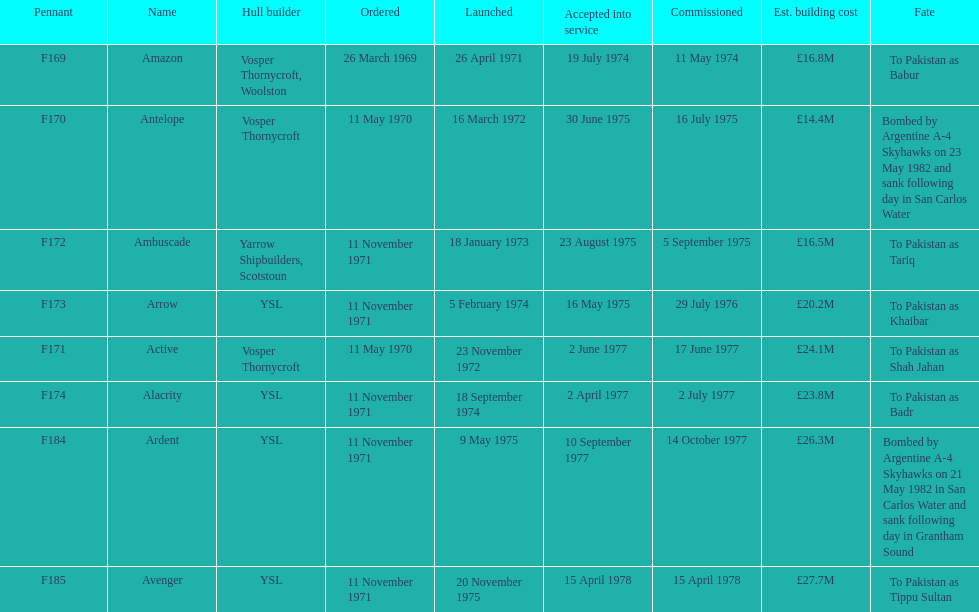What is the name of the ship listed after ardent? Avenger. 